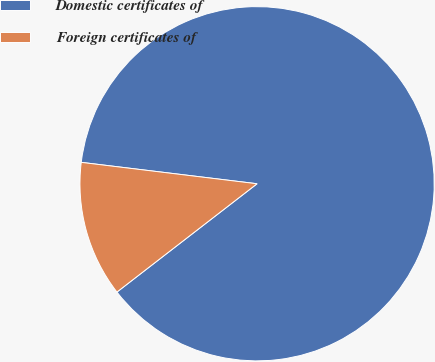Convert chart to OTSL. <chart><loc_0><loc_0><loc_500><loc_500><pie_chart><fcel>Domestic certificates of<fcel>Foreign certificates of<nl><fcel>87.6%<fcel>12.4%<nl></chart> 